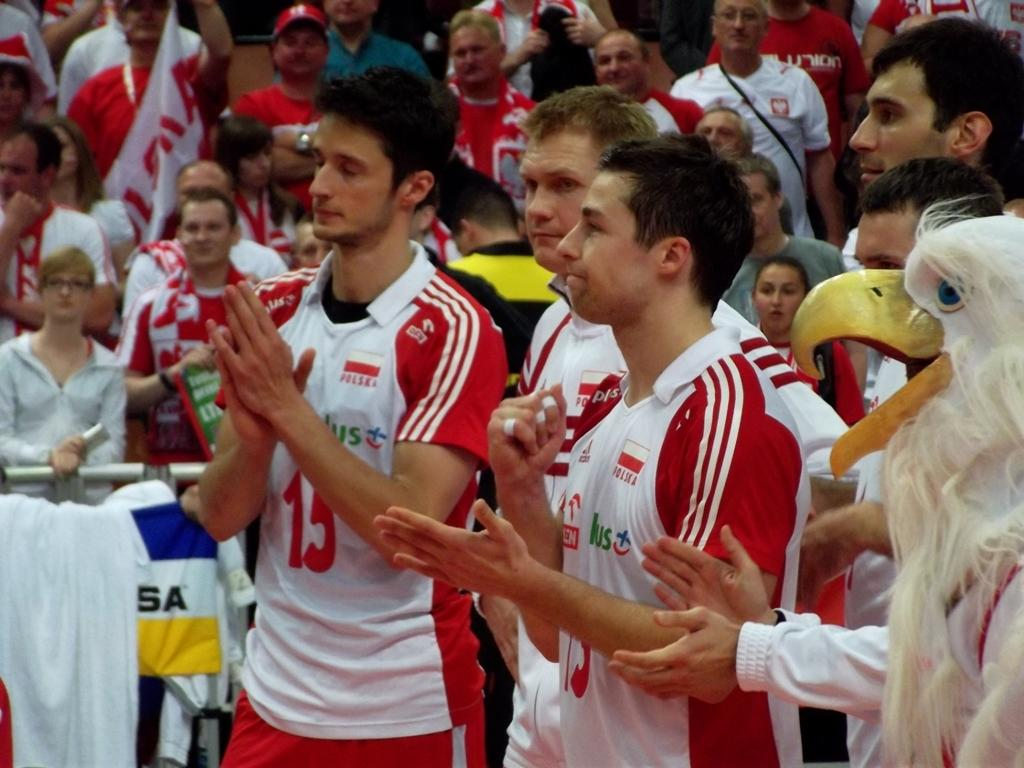<image>
Create a compact narrative representing the image presented. Polish athletes stand next to each other along with an eagle mascot. 